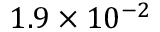<formula> <loc_0><loc_0><loc_500><loc_500>1 . 9 \times 1 0 ^ { - 2 }</formula> 